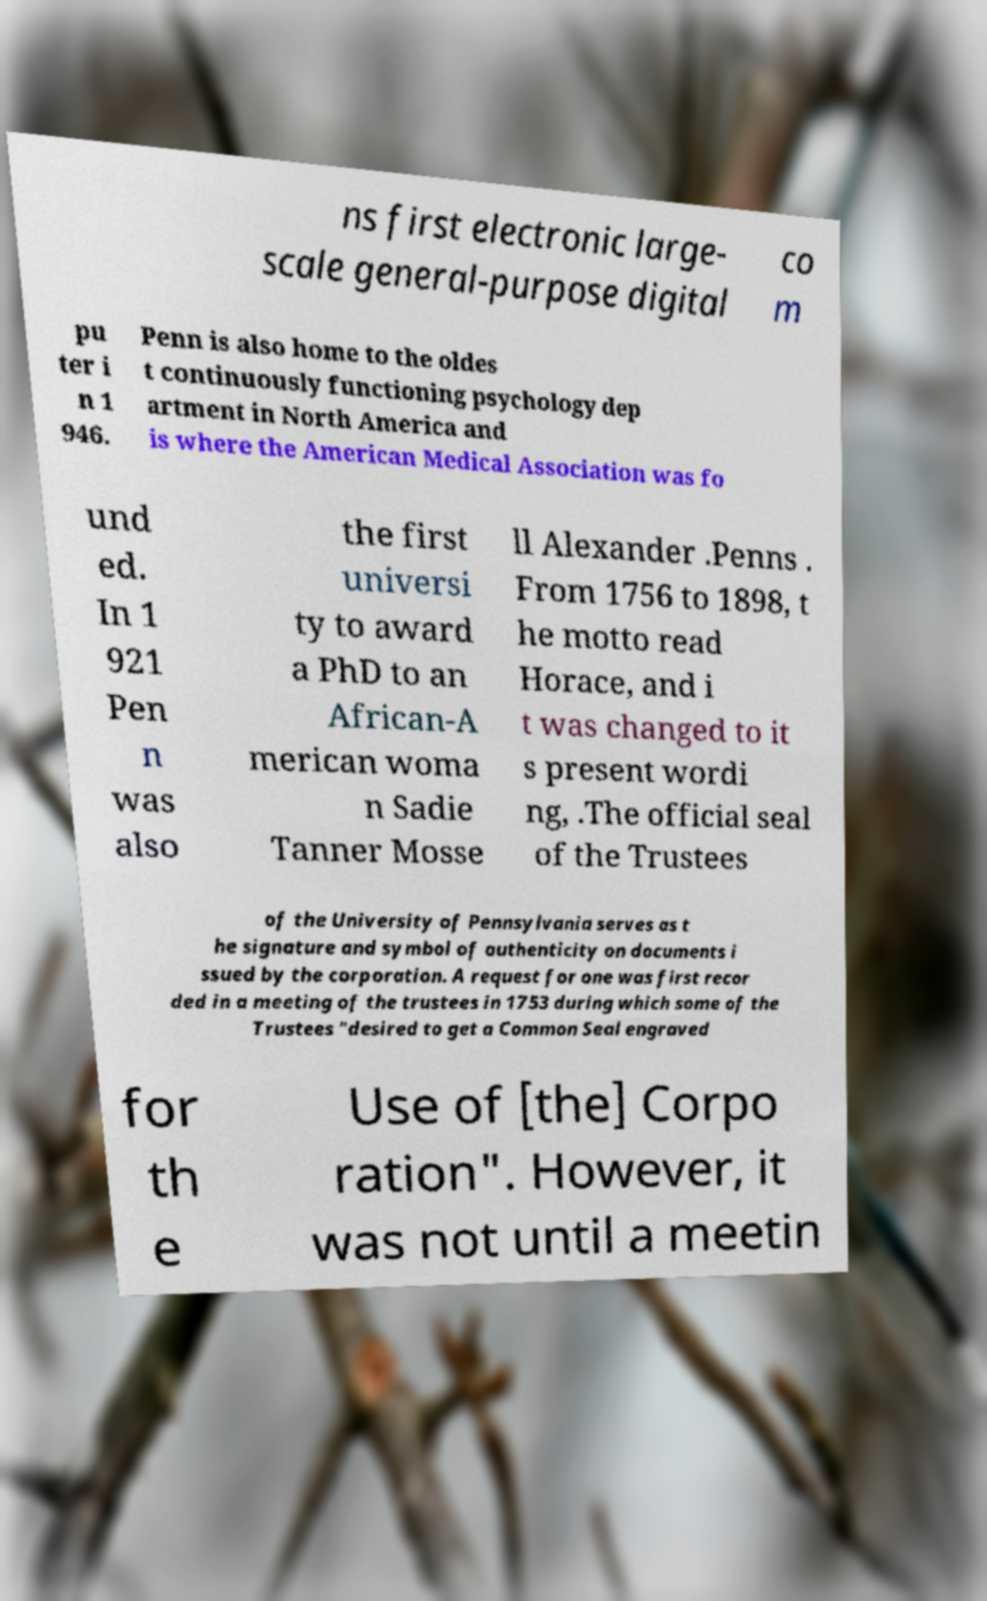For documentation purposes, I need the text within this image transcribed. Could you provide that? ns first electronic large- scale general-purpose digital co m pu ter i n 1 946. Penn is also home to the oldes t continuously functioning psychology dep artment in North America and is where the American Medical Association was fo und ed. In 1 921 Pen n was also the first universi ty to award a PhD to an African-A merican woma n Sadie Tanner Mosse ll Alexander .Penns . From 1756 to 1898, t he motto read Horace, and i t was changed to it s present wordi ng, .The official seal of the Trustees of the University of Pennsylvania serves as t he signature and symbol of authenticity on documents i ssued by the corporation. A request for one was first recor ded in a meeting of the trustees in 1753 during which some of the Trustees "desired to get a Common Seal engraved for th e Use of [the] Corpo ration". However, it was not until a meetin 